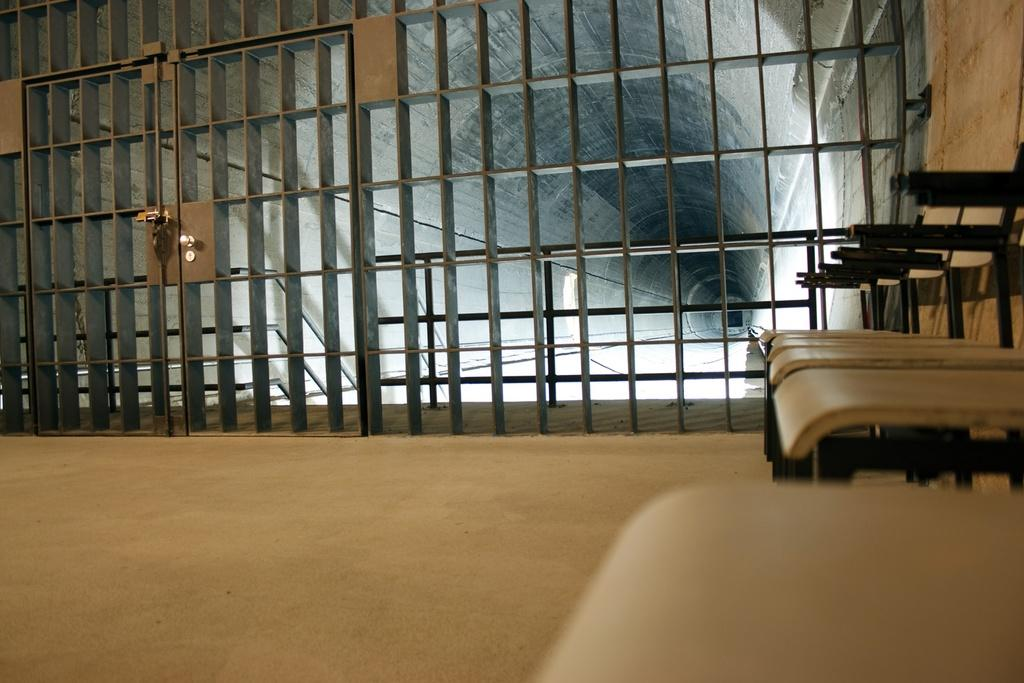What objects are on the ground in the image? There are chairs on the ground in the image. What structure can be seen in the image? There is a gate in the image. What natural feature is present in the image? There is a cave in the image. What is your mom doing in the image? There is no reference to a mom in the image. --- Facts: 1. There is a person in the image. 2. The person is wearing a hat. 3. The person is holding a book. 4. The person is sitting on a bench. 5. There is a tree in the background. Absurd Topics: unicorn, spaceship, alien Conversation: Who or what is present in the image? There is a person in the image. What is the person wearing? The person is wearing a hat. What is the person holding? The person is holding a book. What is the person doing? The person is sitting on a bench. What can be seen in the background? There is a tree in the background. Reasoning: Let's think step by step in order to produce the conversation. We start by identifying the main subject in the image, which is the person. Then, we describe the person's attire, specifically mentioning the hat. Next, we observe the person's actions, noting that they are holding a book. After that, we describe the person's position, which is sitting on a bench. Finally, we describe the background, which includes a tree. Each question is designed to elicit a specific detail about the image that is known from the provided facts. Absurd Question/Answer: Can you see a unicorn spaceship in the image? There is no unicorn spaceship present in the image. --- Facts: 1. There is a dog in the image. 2. The dog is lying down. 3. The dog is wearing a collar. 4. The dog is next to a bowl of water. 5. There is a fence in the background. Absurd Topics: robot, flying saucer, extraterrestrial Conversation: What type of animal is present in the image? There is a dog in the image. What is the dog doing? The dog is lying down. Q:: What is the dog wearing? What is the dog next to? The dog is next to a bowl of water. What can be seen in the background? There is a fence in the background. Reasoning: Let's think step by step in order to produce the conversation. We start by identifying the main subject in the image, which is the dog. Then, we describe the dog's position, noting that it is lying down. Next, we observe the dog's attire, specifically mentioning the collar. After that, we describe the dog's proximity 